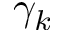<formula> <loc_0><loc_0><loc_500><loc_500>\gamma _ { k }</formula> 